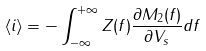<formula> <loc_0><loc_0><loc_500><loc_500>\left < i \right > = - \int _ { - \infty } ^ { + \infty } Z ( f ) \frac { \partial M _ { 2 } ( f ) } { \partial V _ { s } } d f</formula> 